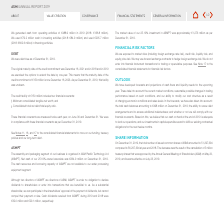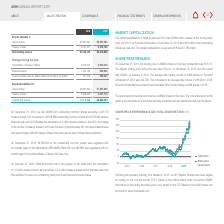From Asm International Nv's financial document, Where are the outstanding common shares registered with in 2019? The document shows two values: Netherlands, ABN AMRO Bank NV and United States, Citibank, NA, New York. From the document: "our transfer agent in the Netherlands, ABN AMRO Bank NV; and 282,880 were registered with our transfer agent in the United States, Citibank, NA, New Y..." Also, What are the issued shares as per january 1 2019? According to the financial document, 56,297,394. The relevant text states: "Issued shares 62,297,394 56,297,394..." Also, Why would it be proposed that treasury share are to be cancelled? the number of 2.4 million treasury shares held at that date was more than sufficient to cover our outstanding options and restricted/performance shares. The document states: "of 1.5 million treasury shares, as the number of 2.4 million treasury shares held at that date was more than sufficient to cover our outstanding optio..." Also, can you calculate: What is the average number of Outstanding shares as per january 1 2018 and 2019?  To answer this question, I need to perform calculations using the financial data. The calculation is: (56,140,153+ 49,318,898 )/2, which equals 52729525.5. This is based on the information: "Outstanding shares 56,140,153 49,318,898 Outstanding shares 56,140,153 49,318,898..." The key data points involved are: 49,318,898, 56,140,153. Additionally, At which point of time was the Outstanding shares the greatest? The document shows two values: January 1 and 2018. From the document: "As per January 1: he credit commitment was December 16, 2021 and in 2018 and in 2019..." Also, can you calculate: What is the change in Outstanding shares as per December 31, 2019 as compared to January 1, 2018? Based on the calculation:  48,866,220-56,140,153, the result is -7273933. This is based on the information: "Outstanding shares 56,140,153 49,318,898 Outstanding shares 49,318,898 48,866,220..." The key data points involved are: 48,866,220, 56,140,153. 